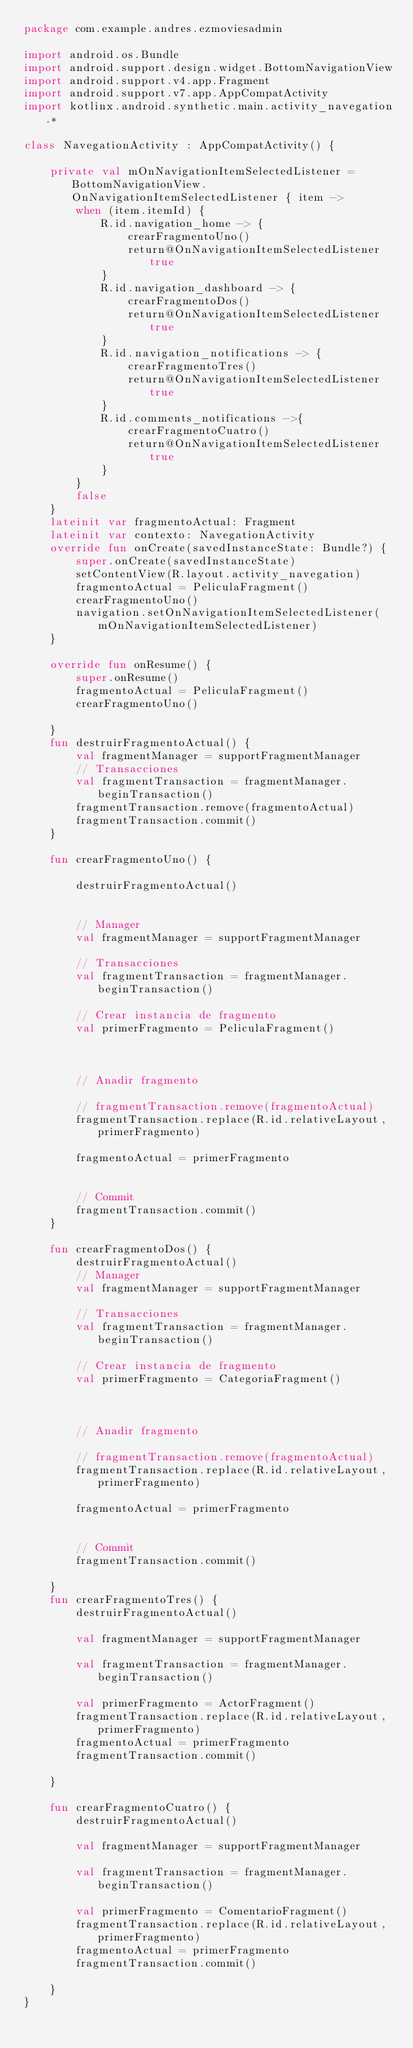<code> <loc_0><loc_0><loc_500><loc_500><_Kotlin_>package com.example.andres.ezmoviesadmin

import android.os.Bundle
import android.support.design.widget.BottomNavigationView
import android.support.v4.app.Fragment
import android.support.v7.app.AppCompatActivity
import kotlinx.android.synthetic.main.activity_navegation.*

class NavegationActivity : AppCompatActivity() {

    private val mOnNavigationItemSelectedListener = BottomNavigationView.OnNavigationItemSelectedListener { item ->
        when (item.itemId) {
            R.id.navigation_home -> {
                crearFragmentoUno()
                return@OnNavigationItemSelectedListener true
            }
            R.id.navigation_dashboard -> {
                crearFragmentoDos()
                return@OnNavigationItemSelectedListener true
            }
            R.id.navigation_notifications -> {
                crearFragmentoTres()
                return@OnNavigationItemSelectedListener true
            }
            R.id.comments_notifications ->{
                crearFragmentoCuatro()
                return@OnNavigationItemSelectedListener true
            }
        }
        false
    }
    lateinit var fragmentoActual: Fragment
    lateinit var contexto: NavegationActivity
    override fun onCreate(savedInstanceState: Bundle?) {
        super.onCreate(savedInstanceState)
        setContentView(R.layout.activity_navegation)
        fragmentoActual = PeliculaFragment()
        crearFragmentoUno()
        navigation.setOnNavigationItemSelectedListener(mOnNavigationItemSelectedListener)
    }

    override fun onResume() {
        super.onResume()
        fragmentoActual = PeliculaFragment()
        crearFragmentoUno()

    }
    fun destruirFragmentoActual() {
        val fragmentManager = supportFragmentManager
        // Transacciones
        val fragmentTransaction = fragmentManager.beginTransaction()
        fragmentTransaction.remove(fragmentoActual)
        fragmentTransaction.commit()
    }

    fun crearFragmentoUno() {

        destruirFragmentoActual()


        // Manager
        val fragmentManager = supportFragmentManager

        // Transacciones
        val fragmentTransaction = fragmentManager.beginTransaction()

        // Crear instancia de fragmento
        val primerFragmento = PeliculaFragment()



        // Anadir fragmento

        // fragmentTransaction.remove(fragmentoActual)
        fragmentTransaction.replace(R.id.relativeLayout, primerFragmento)

        fragmentoActual = primerFragmento


        // Commit
        fragmentTransaction.commit()
    }

    fun crearFragmentoDos() {
        destruirFragmentoActual()
        // Manager
        val fragmentManager = supportFragmentManager

        // Transacciones
        val fragmentTransaction = fragmentManager.beginTransaction()

        // Crear instancia de fragmento
        val primerFragmento = CategoriaFragment()



        // Anadir fragmento

        // fragmentTransaction.remove(fragmentoActual)
        fragmentTransaction.replace(R.id.relativeLayout, primerFragmento)

        fragmentoActual = primerFragmento


        // Commit
        fragmentTransaction.commit()

    }
    fun crearFragmentoTres() {
        destruirFragmentoActual()

        val fragmentManager = supportFragmentManager

        val fragmentTransaction = fragmentManager.beginTransaction()

        val primerFragmento = ActorFragment()
        fragmentTransaction.replace(R.id.relativeLayout, primerFragmento)
        fragmentoActual = primerFragmento
        fragmentTransaction.commit()

    }

    fun crearFragmentoCuatro() {
        destruirFragmentoActual()

        val fragmentManager = supportFragmentManager

        val fragmentTransaction = fragmentManager.beginTransaction()

        val primerFragmento = ComentarioFragment()
        fragmentTransaction.replace(R.id.relativeLayout, primerFragmento)
        fragmentoActual = primerFragmento
        fragmentTransaction.commit()

    }
}
</code> 